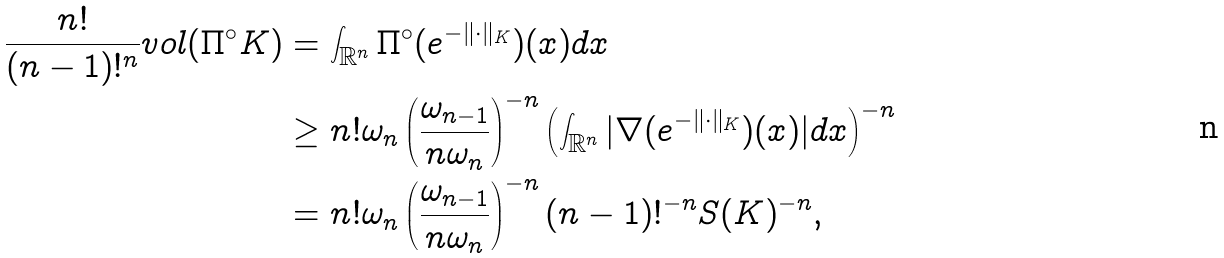Convert formula to latex. <formula><loc_0><loc_0><loc_500><loc_500>\frac { n ! } { ( n - 1 ) ! ^ { n } } v o l ( \Pi ^ { \circ } K ) & = \int _ { \mathbb { R } ^ { n } } \Pi ^ { \circ } ( e ^ { - \| \cdot \| _ { K } } ) ( x ) d x \\ & \geq n ! \omega _ { n } \left ( \frac { \omega _ { n - 1 } } { n \omega _ { n } } \right ) ^ { - n } \left ( \int _ { \mathbb { R } ^ { n } } | \nabla ( e ^ { - \| \cdot \| _ { K } } ) ( x ) | d x \right ) ^ { - n } \\ & = n ! \omega _ { n } \left ( \frac { \omega _ { n - 1 } } { n \omega _ { n } } \right ) ^ { - n } ( n - 1 ) ! ^ { - n } S ( K ) ^ { - n } ,</formula> 